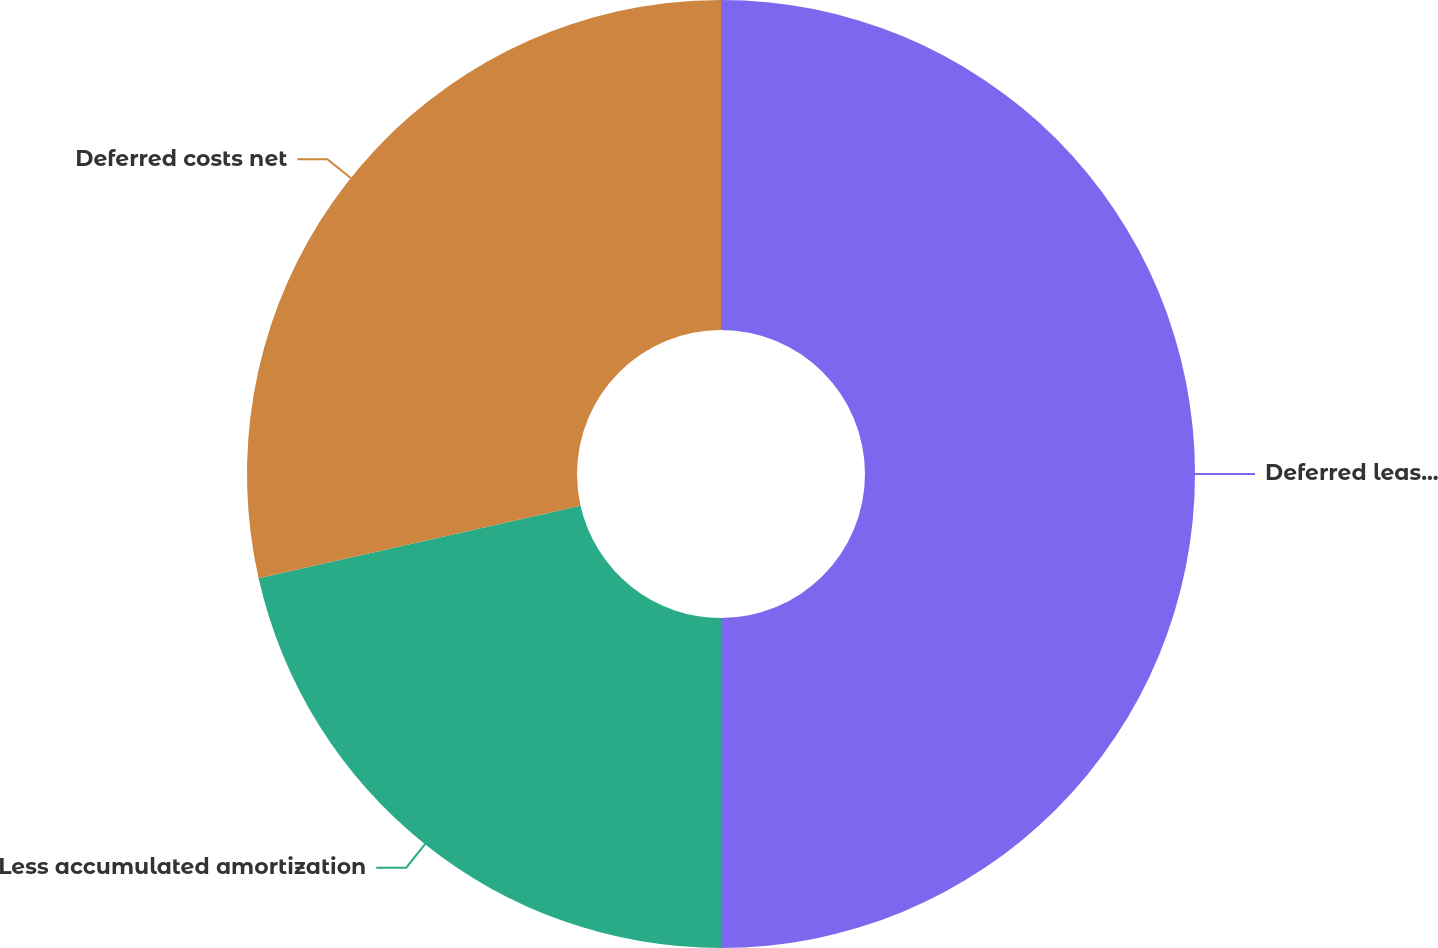<chart> <loc_0><loc_0><loc_500><loc_500><pie_chart><fcel>Deferred leasing costs<fcel>Less accumulated amortization<fcel>Deferred costs net<nl><fcel>50.0%<fcel>21.47%<fcel>28.53%<nl></chart> 